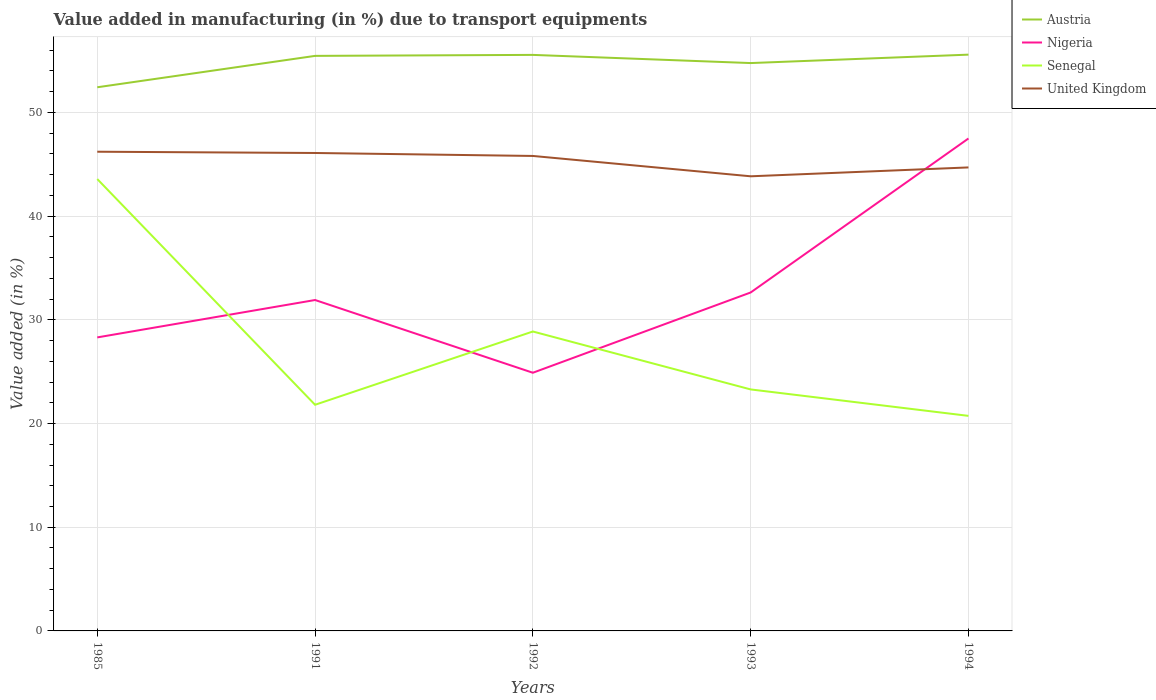How many different coloured lines are there?
Give a very brief answer. 4. Across all years, what is the maximum percentage of value added in manufacturing due to transport equipments in Nigeria?
Offer a terse response. 24.9. In which year was the percentage of value added in manufacturing due to transport equipments in Nigeria maximum?
Your answer should be very brief. 1992. What is the total percentage of value added in manufacturing due to transport equipments in Austria in the graph?
Keep it short and to the point. -0.02. What is the difference between the highest and the second highest percentage of value added in manufacturing due to transport equipments in Austria?
Ensure brevity in your answer.  3.15. What is the difference between the highest and the lowest percentage of value added in manufacturing due to transport equipments in Senegal?
Make the answer very short. 2. Is the percentage of value added in manufacturing due to transport equipments in Nigeria strictly greater than the percentage of value added in manufacturing due to transport equipments in Austria over the years?
Your response must be concise. Yes. How many years are there in the graph?
Give a very brief answer. 5. What is the difference between two consecutive major ticks on the Y-axis?
Offer a terse response. 10. Does the graph contain grids?
Your answer should be very brief. Yes. Where does the legend appear in the graph?
Make the answer very short. Top right. What is the title of the graph?
Make the answer very short. Value added in manufacturing (in %) due to transport equipments. What is the label or title of the Y-axis?
Make the answer very short. Value added (in %). What is the Value added (in %) in Austria in 1985?
Offer a very short reply. 52.43. What is the Value added (in %) of Nigeria in 1985?
Give a very brief answer. 28.31. What is the Value added (in %) of Senegal in 1985?
Provide a short and direct response. 43.58. What is the Value added (in %) in United Kingdom in 1985?
Provide a short and direct response. 46.21. What is the Value added (in %) of Austria in 1991?
Provide a succinct answer. 55.46. What is the Value added (in %) in Nigeria in 1991?
Keep it short and to the point. 31.91. What is the Value added (in %) of Senegal in 1991?
Offer a terse response. 21.81. What is the Value added (in %) in United Kingdom in 1991?
Provide a succinct answer. 46.09. What is the Value added (in %) in Austria in 1992?
Provide a succinct answer. 55.55. What is the Value added (in %) in Nigeria in 1992?
Your answer should be very brief. 24.9. What is the Value added (in %) of Senegal in 1992?
Your response must be concise. 28.88. What is the Value added (in %) in United Kingdom in 1992?
Offer a very short reply. 45.81. What is the Value added (in %) in Austria in 1993?
Offer a very short reply. 54.76. What is the Value added (in %) of Nigeria in 1993?
Provide a short and direct response. 32.64. What is the Value added (in %) in Senegal in 1993?
Offer a very short reply. 23.29. What is the Value added (in %) of United Kingdom in 1993?
Ensure brevity in your answer.  43.84. What is the Value added (in %) of Austria in 1994?
Give a very brief answer. 55.58. What is the Value added (in %) in Nigeria in 1994?
Offer a very short reply. 47.49. What is the Value added (in %) in Senegal in 1994?
Offer a very short reply. 20.74. What is the Value added (in %) in United Kingdom in 1994?
Ensure brevity in your answer.  44.7. Across all years, what is the maximum Value added (in %) in Austria?
Give a very brief answer. 55.58. Across all years, what is the maximum Value added (in %) of Nigeria?
Your answer should be compact. 47.49. Across all years, what is the maximum Value added (in %) of Senegal?
Make the answer very short. 43.58. Across all years, what is the maximum Value added (in %) in United Kingdom?
Give a very brief answer. 46.21. Across all years, what is the minimum Value added (in %) in Austria?
Make the answer very short. 52.43. Across all years, what is the minimum Value added (in %) of Nigeria?
Ensure brevity in your answer.  24.9. Across all years, what is the minimum Value added (in %) in Senegal?
Provide a succinct answer. 20.74. Across all years, what is the minimum Value added (in %) in United Kingdom?
Provide a short and direct response. 43.84. What is the total Value added (in %) in Austria in the graph?
Provide a succinct answer. 273.78. What is the total Value added (in %) of Nigeria in the graph?
Provide a short and direct response. 165.25. What is the total Value added (in %) in Senegal in the graph?
Provide a succinct answer. 138.3. What is the total Value added (in %) in United Kingdom in the graph?
Give a very brief answer. 226.66. What is the difference between the Value added (in %) in Austria in 1985 and that in 1991?
Offer a very short reply. -3.03. What is the difference between the Value added (in %) in Nigeria in 1985 and that in 1991?
Your answer should be very brief. -3.61. What is the difference between the Value added (in %) of Senegal in 1985 and that in 1991?
Keep it short and to the point. 21.77. What is the difference between the Value added (in %) of United Kingdom in 1985 and that in 1991?
Offer a terse response. 0.12. What is the difference between the Value added (in %) of Austria in 1985 and that in 1992?
Give a very brief answer. -3.12. What is the difference between the Value added (in %) in Nigeria in 1985 and that in 1992?
Your answer should be compact. 3.41. What is the difference between the Value added (in %) of Senegal in 1985 and that in 1992?
Provide a succinct answer. 14.7. What is the difference between the Value added (in %) in United Kingdom in 1985 and that in 1992?
Your answer should be very brief. 0.41. What is the difference between the Value added (in %) in Austria in 1985 and that in 1993?
Ensure brevity in your answer.  -2.33. What is the difference between the Value added (in %) in Nigeria in 1985 and that in 1993?
Offer a very short reply. -4.33. What is the difference between the Value added (in %) in Senegal in 1985 and that in 1993?
Your answer should be compact. 20.29. What is the difference between the Value added (in %) of United Kingdom in 1985 and that in 1993?
Your response must be concise. 2.37. What is the difference between the Value added (in %) in Austria in 1985 and that in 1994?
Offer a terse response. -3.15. What is the difference between the Value added (in %) in Nigeria in 1985 and that in 1994?
Ensure brevity in your answer.  -19.18. What is the difference between the Value added (in %) of Senegal in 1985 and that in 1994?
Provide a succinct answer. 22.84. What is the difference between the Value added (in %) in United Kingdom in 1985 and that in 1994?
Provide a succinct answer. 1.51. What is the difference between the Value added (in %) of Austria in 1991 and that in 1992?
Offer a terse response. -0.09. What is the difference between the Value added (in %) in Nigeria in 1991 and that in 1992?
Your answer should be very brief. 7.01. What is the difference between the Value added (in %) of Senegal in 1991 and that in 1992?
Your response must be concise. -7.07. What is the difference between the Value added (in %) in United Kingdom in 1991 and that in 1992?
Provide a short and direct response. 0.29. What is the difference between the Value added (in %) of Austria in 1991 and that in 1993?
Ensure brevity in your answer.  0.69. What is the difference between the Value added (in %) of Nigeria in 1991 and that in 1993?
Your answer should be very brief. -0.73. What is the difference between the Value added (in %) of Senegal in 1991 and that in 1993?
Ensure brevity in your answer.  -1.48. What is the difference between the Value added (in %) of United Kingdom in 1991 and that in 1993?
Offer a very short reply. 2.25. What is the difference between the Value added (in %) in Austria in 1991 and that in 1994?
Your response must be concise. -0.12. What is the difference between the Value added (in %) in Nigeria in 1991 and that in 1994?
Your answer should be compact. -15.58. What is the difference between the Value added (in %) of Senegal in 1991 and that in 1994?
Provide a succinct answer. 1.07. What is the difference between the Value added (in %) in United Kingdom in 1991 and that in 1994?
Keep it short and to the point. 1.39. What is the difference between the Value added (in %) of Austria in 1992 and that in 1993?
Keep it short and to the point. 0.79. What is the difference between the Value added (in %) in Nigeria in 1992 and that in 1993?
Your response must be concise. -7.74. What is the difference between the Value added (in %) of Senegal in 1992 and that in 1993?
Give a very brief answer. 5.59. What is the difference between the Value added (in %) of United Kingdom in 1992 and that in 1993?
Provide a succinct answer. 1.96. What is the difference between the Value added (in %) of Austria in 1992 and that in 1994?
Your response must be concise. -0.02. What is the difference between the Value added (in %) of Nigeria in 1992 and that in 1994?
Your answer should be very brief. -22.59. What is the difference between the Value added (in %) in Senegal in 1992 and that in 1994?
Offer a very short reply. 8.14. What is the difference between the Value added (in %) in United Kingdom in 1992 and that in 1994?
Ensure brevity in your answer.  1.11. What is the difference between the Value added (in %) in Austria in 1993 and that in 1994?
Give a very brief answer. -0.81. What is the difference between the Value added (in %) in Nigeria in 1993 and that in 1994?
Keep it short and to the point. -14.85. What is the difference between the Value added (in %) of Senegal in 1993 and that in 1994?
Offer a very short reply. 2.55. What is the difference between the Value added (in %) in United Kingdom in 1993 and that in 1994?
Offer a very short reply. -0.86. What is the difference between the Value added (in %) in Austria in 1985 and the Value added (in %) in Nigeria in 1991?
Your answer should be very brief. 20.52. What is the difference between the Value added (in %) of Austria in 1985 and the Value added (in %) of Senegal in 1991?
Give a very brief answer. 30.62. What is the difference between the Value added (in %) of Austria in 1985 and the Value added (in %) of United Kingdom in 1991?
Provide a succinct answer. 6.34. What is the difference between the Value added (in %) in Nigeria in 1985 and the Value added (in %) in Senegal in 1991?
Your answer should be very brief. 6.5. What is the difference between the Value added (in %) in Nigeria in 1985 and the Value added (in %) in United Kingdom in 1991?
Keep it short and to the point. -17.79. What is the difference between the Value added (in %) of Senegal in 1985 and the Value added (in %) of United Kingdom in 1991?
Ensure brevity in your answer.  -2.51. What is the difference between the Value added (in %) in Austria in 1985 and the Value added (in %) in Nigeria in 1992?
Make the answer very short. 27.53. What is the difference between the Value added (in %) of Austria in 1985 and the Value added (in %) of Senegal in 1992?
Your answer should be very brief. 23.55. What is the difference between the Value added (in %) of Austria in 1985 and the Value added (in %) of United Kingdom in 1992?
Ensure brevity in your answer.  6.62. What is the difference between the Value added (in %) of Nigeria in 1985 and the Value added (in %) of Senegal in 1992?
Provide a succinct answer. -0.57. What is the difference between the Value added (in %) in Nigeria in 1985 and the Value added (in %) in United Kingdom in 1992?
Offer a terse response. -17.5. What is the difference between the Value added (in %) of Senegal in 1985 and the Value added (in %) of United Kingdom in 1992?
Your response must be concise. -2.23. What is the difference between the Value added (in %) in Austria in 1985 and the Value added (in %) in Nigeria in 1993?
Make the answer very short. 19.79. What is the difference between the Value added (in %) in Austria in 1985 and the Value added (in %) in Senegal in 1993?
Offer a very short reply. 29.14. What is the difference between the Value added (in %) of Austria in 1985 and the Value added (in %) of United Kingdom in 1993?
Your answer should be very brief. 8.59. What is the difference between the Value added (in %) in Nigeria in 1985 and the Value added (in %) in Senegal in 1993?
Provide a short and direct response. 5.02. What is the difference between the Value added (in %) of Nigeria in 1985 and the Value added (in %) of United Kingdom in 1993?
Give a very brief answer. -15.54. What is the difference between the Value added (in %) of Senegal in 1985 and the Value added (in %) of United Kingdom in 1993?
Your response must be concise. -0.26. What is the difference between the Value added (in %) in Austria in 1985 and the Value added (in %) in Nigeria in 1994?
Offer a terse response. 4.94. What is the difference between the Value added (in %) of Austria in 1985 and the Value added (in %) of Senegal in 1994?
Ensure brevity in your answer.  31.69. What is the difference between the Value added (in %) in Austria in 1985 and the Value added (in %) in United Kingdom in 1994?
Make the answer very short. 7.73. What is the difference between the Value added (in %) in Nigeria in 1985 and the Value added (in %) in Senegal in 1994?
Provide a short and direct response. 7.57. What is the difference between the Value added (in %) of Nigeria in 1985 and the Value added (in %) of United Kingdom in 1994?
Provide a short and direct response. -16.39. What is the difference between the Value added (in %) in Senegal in 1985 and the Value added (in %) in United Kingdom in 1994?
Provide a succinct answer. -1.12. What is the difference between the Value added (in %) in Austria in 1991 and the Value added (in %) in Nigeria in 1992?
Provide a succinct answer. 30.56. What is the difference between the Value added (in %) of Austria in 1991 and the Value added (in %) of Senegal in 1992?
Keep it short and to the point. 26.58. What is the difference between the Value added (in %) of Austria in 1991 and the Value added (in %) of United Kingdom in 1992?
Ensure brevity in your answer.  9.65. What is the difference between the Value added (in %) of Nigeria in 1991 and the Value added (in %) of Senegal in 1992?
Keep it short and to the point. 3.04. What is the difference between the Value added (in %) of Nigeria in 1991 and the Value added (in %) of United Kingdom in 1992?
Ensure brevity in your answer.  -13.89. What is the difference between the Value added (in %) in Senegal in 1991 and the Value added (in %) in United Kingdom in 1992?
Give a very brief answer. -24. What is the difference between the Value added (in %) in Austria in 1991 and the Value added (in %) in Nigeria in 1993?
Your answer should be very brief. 22.82. What is the difference between the Value added (in %) of Austria in 1991 and the Value added (in %) of Senegal in 1993?
Your answer should be very brief. 32.17. What is the difference between the Value added (in %) in Austria in 1991 and the Value added (in %) in United Kingdom in 1993?
Offer a very short reply. 11.61. What is the difference between the Value added (in %) of Nigeria in 1991 and the Value added (in %) of Senegal in 1993?
Offer a very short reply. 8.62. What is the difference between the Value added (in %) in Nigeria in 1991 and the Value added (in %) in United Kingdom in 1993?
Make the answer very short. -11.93. What is the difference between the Value added (in %) of Senegal in 1991 and the Value added (in %) of United Kingdom in 1993?
Offer a very short reply. -22.03. What is the difference between the Value added (in %) of Austria in 1991 and the Value added (in %) of Nigeria in 1994?
Keep it short and to the point. 7.97. What is the difference between the Value added (in %) of Austria in 1991 and the Value added (in %) of Senegal in 1994?
Offer a terse response. 34.72. What is the difference between the Value added (in %) of Austria in 1991 and the Value added (in %) of United Kingdom in 1994?
Keep it short and to the point. 10.76. What is the difference between the Value added (in %) in Nigeria in 1991 and the Value added (in %) in Senegal in 1994?
Your answer should be very brief. 11.17. What is the difference between the Value added (in %) of Nigeria in 1991 and the Value added (in %) of United Kingdom in 1994?
Keep it short and to the point. -12.79. What is the difference between the Value added (in %) of Senegal in 1991 and the Value added (in %) of United Kingdom in 1994?
Give a very brief answer. -22.89. What is the difference between the Value added (in %) of Austria in 1992 and the Value added (in %) of Nigeria in 1993?
Provide a short and direct response. 22.91. What is the difference between the Value added (in %) of Austria in 1992 and the Value added (in %) of Senegal in 1993?
Your answer should be compact. 32.26. What is the difference between the Value added (in %) of Austria in 1992 and the Value added (in %) of United Kingdom in 1993?
Provide a succinct answer. 11.71. What is the difference between the Value added (in %) of Nigeria in 1992 and the Value added (in %) of Senegal in 1993?
Your answer should be compact. 1.61. What is the difference between the Value added (in %) of Nigeria in 1992 and the Value added (in %) of United Kingdom in 1993?
Provide a short and direct response. -18.95. What is the difference between the Value added (in %) in Senegal in 1992 and the Value added (in %) in United Kingdom in 1993?
Ensure brevity in your answer.  -14.97. What is the difference between the Value added (in %) of Austria in 1992 and the Value added (in %) of Nigeria in 1994?
Keep it short and to the point. 8.06. What is the difference between the Value added (in %) of Austria in 1992 and the Value added (in %) of Senegal in 1994?
Provide a succinct answer. 34.81. What is the difference between the Value added (in %) of Austria in 1992 and the Value added (in %) of United Kingdom in 1994?
Keep it short and to the point. 10.85. What is the difference between the Value added (in %) in Nigeria in 1992 and the Value added (in %) in Senegal in 1994?
Offer a terse response. 4.16. What is the difference between the Value added (in %) in Nigeria in 1992 and the Value added (in %) in United Kingdom in 1994?
Give a very brief answer. -19.8. What is the difference between the Value added (in %) in Senegal in 1992 and the Value added (in %) in United Kingdom in 1994?
Offer a terse response. -15.82. What is the difference between the Value added (in %) of Austria in 1993 and the Value added (in %) of Nigeria in 1994?
Provide a short and direct response. 7.27. What is the difference between the Value added (in %) of Austria in 1993 and the Value added (in %) of Senegal in 1994?
Ensure brevity in your answer.  34.02. What is the difference between the Value added (in %) of Austria in 1993 and the Value added (in %) of United Kingdom in 1994?
Offer a very short reply. 10.06. What is the difference between the Value added (in %) of Nigeria in 1993 and the Value added (in %) of Senegal in 1994?
Offer a very short reply. 11.9. What is the difference between the Value added (in %) in Nigeria in 1993 and the Value added (in %) in United Kingdom in 1994?
Make the answer very short. -12.06. What is the difference between the Value added (in %) of Senegal in 1993 and the Value added (in %) of United Kingdom in 1994?
Ensure brevity in your answer.  -21.41. What is the average Value added (in %) in Austria per year?
Your response must be concise. 54.76. What is the average Value added (in %) in Nigeria per year?
Offer a terse response. 33.05. What is the average Value added (in %) of Senegal per year?
Ensure brevity in your answer.  27.66. What is the average Value added (in %) in United Kingdom per year?
Give a very brief answer. 45.33. In the year 1985, what is the difference between the Value added (in %) of Austria and Value added (in %) of Nigeria?
Keep it short and to the point. 24.12. In the year 1985, what is the difference between the Value added (in %) in Austria and Value added (in %) in Senegal?
Offer a terse response. 8.85. In the year 1985, what is the difference between the Value added (in %) in Austria and Value added (in %) in United Kingdom?
Provide a short and direct response. 6.22. In the year 1985, what is the difference between the Value added (in %) in Nigeria and Value added (in %) in Senegal?
Offer a very short reply. -15.27. In the year 1985, what is the difference between the Value added (in %) in Nigeria and Value added (in %) in United Kingdom?
Make the answer very short. -17.91. In the year 1985, what is the difference between the Value added (in %) in Senegal and Value added (in %) in United Kingdom?
Your answer should be compact. -2.63. In the year 1991, what is the difference between the Value added (in %) in Austria and Value added (in %) in Nigeria?
Offer a very short reply. 23.54. In the year 1991, what is the difference between the Value added (in %) in Austria and Value added (in %) in Senegal?
Provide a succinct answer. 33.65. In the year 1991, what is the difference between the Value added (in %) of Austria and Value added (in %) of United Kingdom?
Your answer should be compact. 9.37. In the year 1991, what is the difference between the Value added (in %) in Nigeria and Value added (in %) in Senegal?
Your response must be concise. 10.1. In the year 1991, what is the difference between the Value added (in %) of Nigeria and Value added (in %) of United Kingdom?
Your answer should be very brief. -14.18. In the year 1991, what is the difference between the Value added (in %) of Senegal and Value added (in %) of United Kingdom?
Make the answer very short. -24.28. In the year 1992, what is the difference between the Value added (in %) in Austria and Value added (in %) in Nigeria?
Your response must be concise. 30.65. In the year 1992, what is the difference between the Value added (in %) of Austria and Value added (in %) of Senegal?
Offer a very short reply. 26.68. In the year 1992, what is the difference between the Value added (in %) in Austria and Value added (in %) in United Kingdom?
Offer a very short reply. 9.75. In the year 1992, what is the difference between the Value added (in %) of Nigeria and Value added (in %) of Senegal?
Give a very brief answer. -3.98. In the year 1992, what is the difference between the Value added (in %) of Nigeria and Value added (in %) of United Kingdom?
Ensure brevity in your answer.  -20.91. In the year 1992, what is the difference between the Value added (in %) of Senegal and Value added (in %) of United Kingdom?
Your answer should be compact. -16.93. In the year 1993, what is the difference between the Value added (in %) of Austria and Value added (in %) of Nigeria?
Provide a short and direct response. 22.13. In the year 1993, what is the difference between the Value added (in %) of Austria and Value added (in %) of Senegal?
Give a very brief answer. 31.48. In the year 1993, what is the difference between the Value added (in %) in Austria and Value added (in %) in United Kingdom?
Ensure brevity in your answer.  10.92. In the year 1993, what is the difference between the Value added (in %) of Nigeria and Value added (in %) of Senegal?
Offer a terse response. 9.35. In the year 1993, what is the difference between the Value added (in %) in Nigeria and Value added (in %) in United Kingdom?
Offer a very short reply. -11.21. In the year 1993, what is the difference between the Value added (in %) in Senegal and Value added (in %) in United Kingdom?
Make the answer very short. -20.56. In the year 1994, what is the difference between the Value added (in %) in Austria and Value added (in %) in Nigeria?
Your answer should be very brief. 8.09. In the year 1994, what is the difference between the Value added (in %) of Austria and Value added (in %) of Senegal?
Give a very brief answer. 34.84. In the year 1994, what is the difference between the Value added (in %) of Austria and Value added (in %) of United Kingdom?
Give a very brief answer. 10.88. In the year 1994, what is the difference between the Value added (in %) of Nigeria and Value added (in %) of Senegal?
Keep it short and to the point. 26.75. In the year 1994, what is the difference between the Value added (in %) of Nigeria and Value added (in %) of United Kingdom?
Give a very brief answer. 2.79. In the year 1994, what is the difference between the Value added (in %) in Senegal and Value added (in %) in United Kingdom?
Ensure brevity in your answer.  -23.96. What is the ratio of the Value added (in %) of Austria in 1985 to that in 1991?
Your answer should be very brief. 0.95. What is the ratio of the Value added (in %) of Nigeria in 1985 to that in 1991?
Keep it short and to the point. 0.89. What is the ratio of the Value added (in %) of Senegal in 1985 to that in 1991?
Offer a terse response. 2. What is the ratio of the Value added (in %) of United Kingdom in 1985 to that in 1991?
Your answer should be compact. 1. What is the ratio of the Value added (in %) in Austria in 1985 to that in 1992?
Offer a terse response. 0.94. What is the ratio of the Value added (in %) of Nigeria in 1985 to that in 1992?
Offer a very short reply. 1.14. What is the ratio of the Value added (in %) of Senegal in 1985 to that in 1992?
Keep it short and to the point. 1.51. What is the ratio of the Value added (in %) in United Kingdom in 1985 to that in 1992?
Offer a very short reply. 1.01. What is the ratio of the Value added (in %) in Austria in 1985 to that in 1993?
Provide a succinct answer. 0.96. What is the ratio of the Value added (in %) in Nigeria in 1985 to that in 1993?
Offer a terse response. 0.87. What is the ratio of the Value added (in %) in Senegal in 1985 to that in 1993?
Make the answer very short. 1.87. What is the ratio of the Value added (in %) in United Kingdom in 1985 to that in 1993?
Make the answer very short. 1.05. What is the ratio of the Value added (in %) of Austria in 1985 to that in 1994?
Give a very brief answer. 0.94. What is the ratio of the Value added (in %) in Nigeria in 1985 to that in 1994?
Your response must be concise. 0.6. What is the ratio of the Value added (in %) of Senegal in 1985 to that in 1994?
Offer a very short reply. 2.1. What is the ratio of the Value added (in %) in United Kingdom in 1985 to that in 1994?
Offer a very short reply. 1.03. What is the ratio of the Value added (in %) in Nigeria in 1991 to that in 1992?
Ensure brevity in your answer.  1.28. What is the ratio of the Value added (in %) in Senegal in 1991 to that in 1992?
Your answer should be compact. 0.76. What is the ratio of the Value added (in %) in United Kingdom in 1991 to that in 1992?
Your answer should be compact. 1.01. What is the ratio of the Value added (in %) of Austria in 1991 to that in 1993?
Your response must be concise. 1.01. What is the ratio of the Value added (in %) in Nigeria in 1991 to that in 1993?
Provide a succinct answer. 0.98. What is the ratio of the Value added (in %) in Senegal in 1991 to that in 1993?
Provide a succinct answer. 0.94. What is the ratio of the Value added (in %) in United Kingdom in 1991 to that in 1993?
Ensure brevity in your answer.  1.05. What is the ratio of the Value added (in %) of Nigeria in 1991 to that in 1994?
Your response must be concise. 0.67. What is the ratio of the Value added (in %) of Senegal in 1991 to that in 1994?
Offer a terse response. 1.05. What is the ratio of the Value added (in %) in United Kingdom in 1991 to that in 1994?
Ensure brevity in your answer.  1.03. What is the ratio of the Value added (in %) of Austria in 1992 to that in 1993?
Give a very brief answer. 1.01. What is the ratio of the Value added (in %) of Nigeria in 1992 to that in 1993?
Give a very brief answer. 0.76. What is the ratio of the Value added (in %) of Senegal in 1992 to that in 1993?
Your response must be concise. 1.24. What is the ratio of the Value added (in %) of United Kingdom in 1992 to that in 1993?
Your answer should be compact. 1.04. What is the ratio of the Value added (in %) in Nigeria in 1992 to that in 1994?
Offer a terse response. 0.52. What is the ratio of the Value added (in %) in Senegal in 1992 to that in 1994?
Provide a short and direct response. 1.39. What is the ratio of the Value added (in %) in United Kingdom in 1992 to that in 1994?
Offer a terse response. 1.02. What is the ratio of the Value added (in %) of Austria in 1993 to that in 1994?
Offer a terse response. 0.99. What is the ratio of the Value added (in %) of Nigeria in 1993 to that in 1994?
Ensure brevity in your answer.  0.69. What is the ratio of the Value added (in %) in Senegal in 1993 to that in 1994?
Your answer should be compact. 1.12. What is the ratio of the Value added (in %) of United Kingdom in 1993 to that in 1994?
Provide a succinct answer. 0.98. What is the difference between the highest and the second highest Value added (in %) in Austria?
Offer a very short reply. 0.02. What is the difference between the highest and the second highest Value added (in %) in Nigeria?
Your answer should be very brief. 14.85. What is the difference between the highest and the second highest Value added (in %) in Senegal?
Your answer should be compact. 14.7. What is the difference between the highest and the second highest Value added (in %) in United Kingdom?
Provide a short and direct response. 0.12. What is the difference between the highest and the lowest Value added (in %) of Austria?
Give a very brief answer. 3.15. What is the difference between the highest and the lowest Value added (in %) in Nigeria?
Offer a terse response. 22.59. What is the difference between the highest and the lowest Value added (in %) of Senegal?
Offer a terse response. 22.84. What is the difference between the highest and the lowest Value added (in %) of United Kingdom?
Make the answer very short. 2.37. 